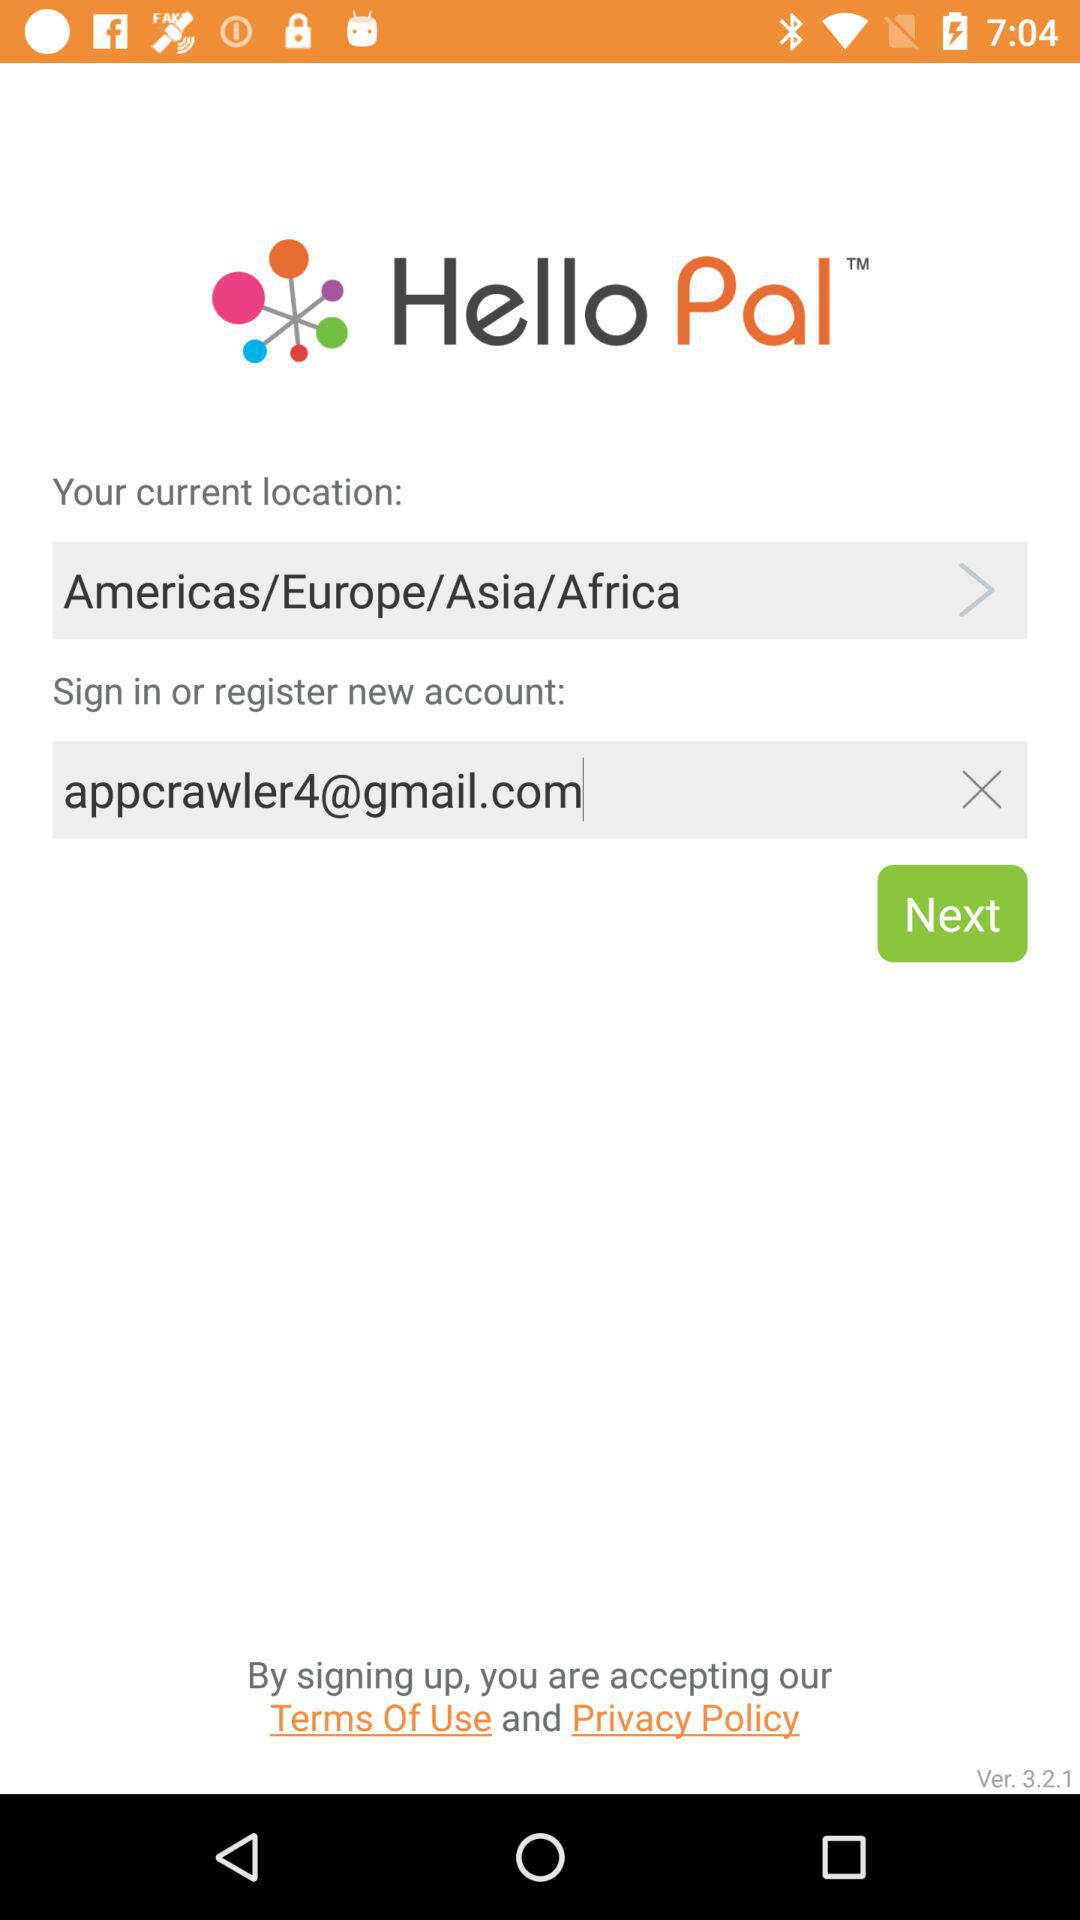How many text inputs have a value?
Answer the question using a single word or phrase. 1 